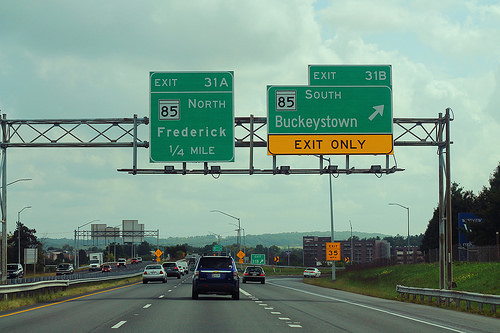<image>
Is the car next to the car? Yes. The car is positioned adjacent to the car, located nearby in the same general area. Is there a sign in front of the sky? Yes. The sign is positioned in front of the sky, appearing closer to the camera viewpoint. 